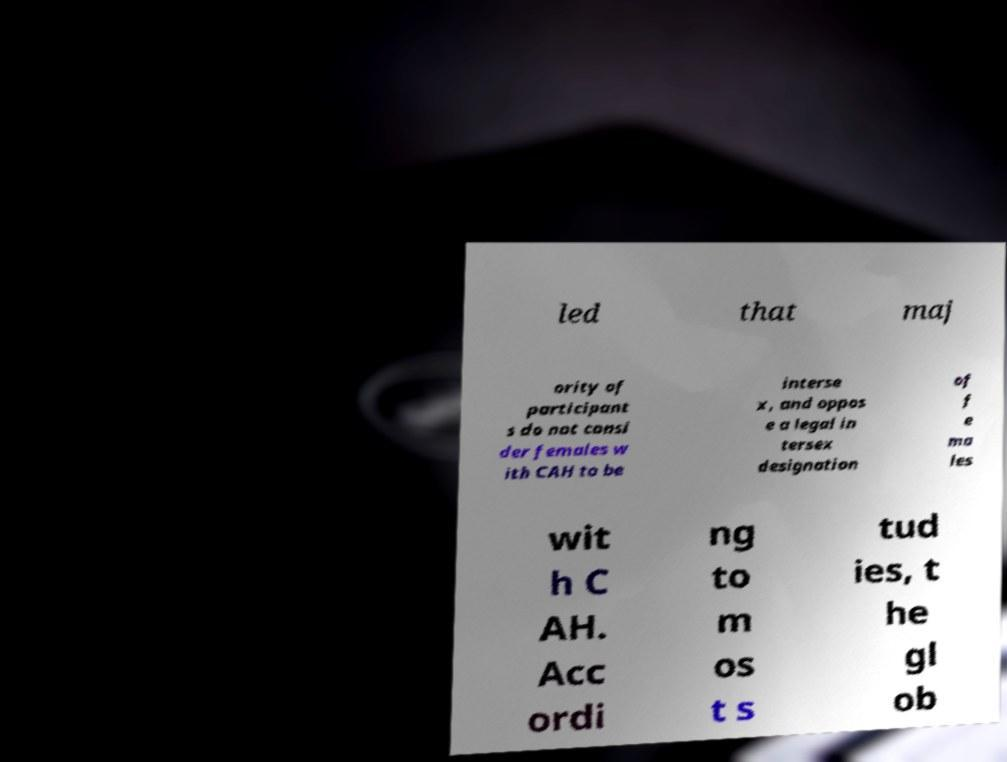Can you read and provide the text displayed in the image?This photo seems to have some interesting text. Can you extract and type it out for me? led that maj ority of participant s do not consi der females w ith CAH to be interse x, and oppos e a legal in tersex designation of f e ma les wit h C AH. Acc ordi ng to m os t s tud ies, t he gl ob 